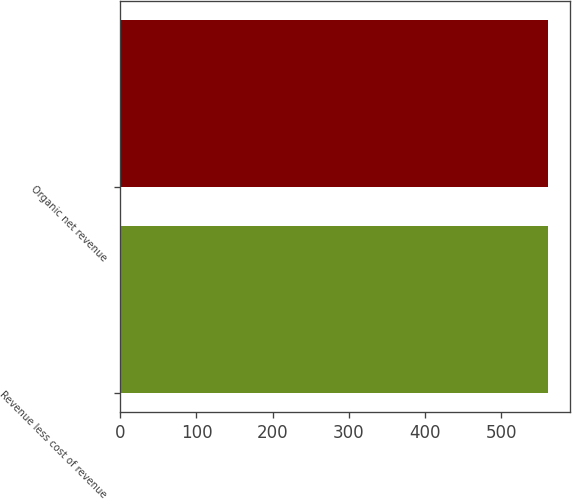<chart> <loc_0><loc_0><loc_500><loc_500><bar_chart><fcel>Revenue less cost of revenue<fcel>Organic net revenue<nl><fcel>561.7<fcel>561.8<nl></chart> 